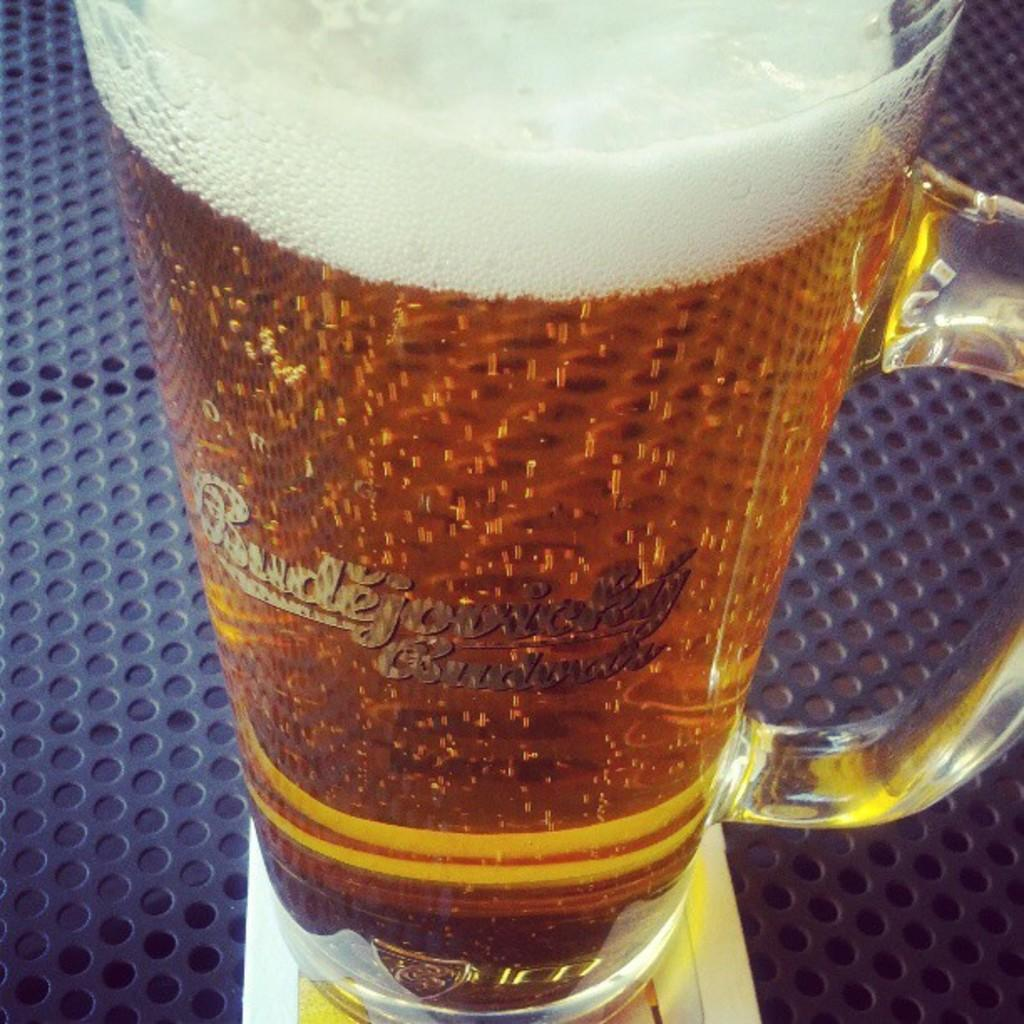<image>
Offer a succinct explanation of the picture presented. On a metal surface painted blue and full of holes sits a tall mug of Budejovicky. 